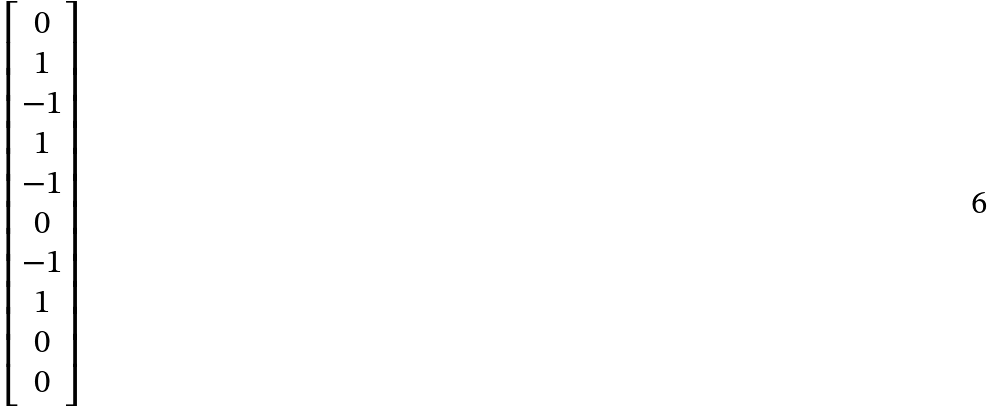<formula> <loc_0><loc_0><loc_500><loc_500>\begin{bmatrix} 0 \\ 1 \\ - 1 \\ 1 \\ - 1 \\ 0 \\ - 1 \\ 1 \\ 0 \\ 0 \end{bmatrix}</formula> 